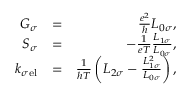Convert formula to latex. <formula><loc_0><loc_0><loc_500><loc_500>\begin{array} { r l r } { G _ { \sigma } } & { = } & { \frac { e ^ { 2 } } { h } L _ { 0 \sigma } , } \\ { S _ { \sigma } } & { = } & { - \frac { 1 } { e T } \frac { L _ { 1 \sigma } } { L _ { 0 \sigma } } , } \\ { k _ { \sigma e l } } & { = } & { \frac { 1 } { h T } \left ( L _ { 2 \sigma } - \frac { L _ { 1 \sigma } ^ { 2 } } { L _ { 0 \sigma } } \right ) , } \end{array}</formula> 